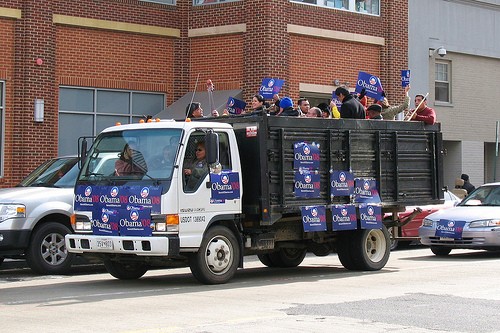Please provide a short description for this region: [0.36, 0.45, 0.42, 0.56]. A woman dressed in a gray-green sweater and sunglasses is seen. 